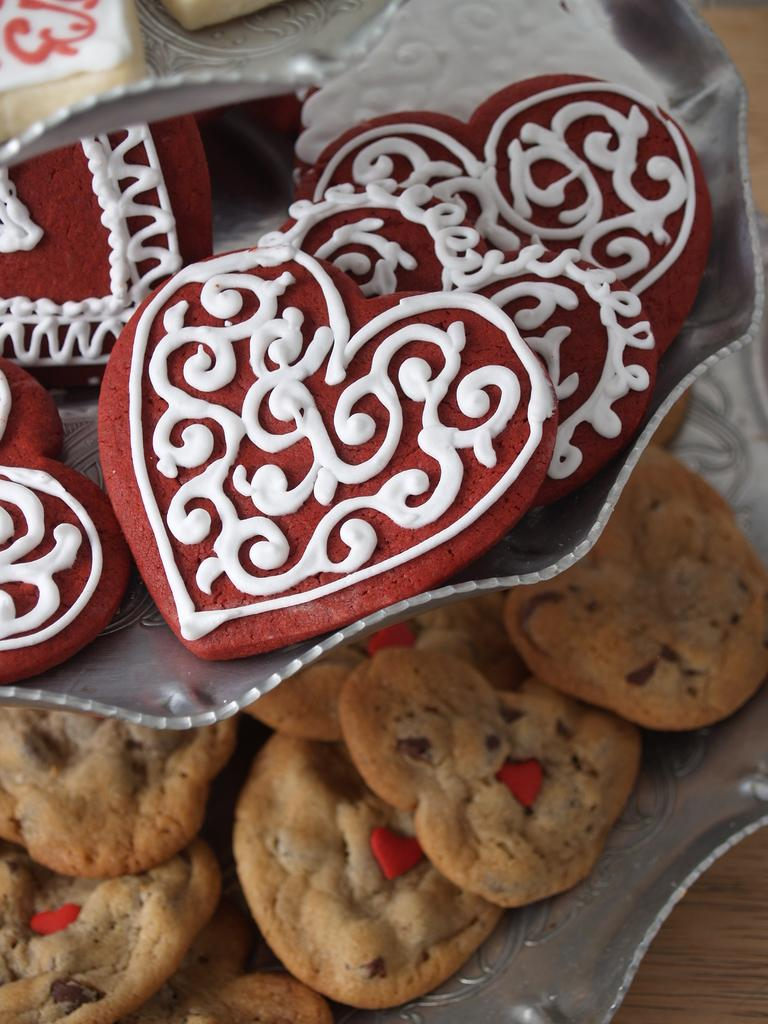What type of food is on the plate in the image? There are cookies on a plate in the image. Where is the plate with cookies located? The plate with cookies is on a table. What type of rice can be seen stretching across the table in the image? There is no rice present in the image, and therefore no stretching rice cannot be observed. 